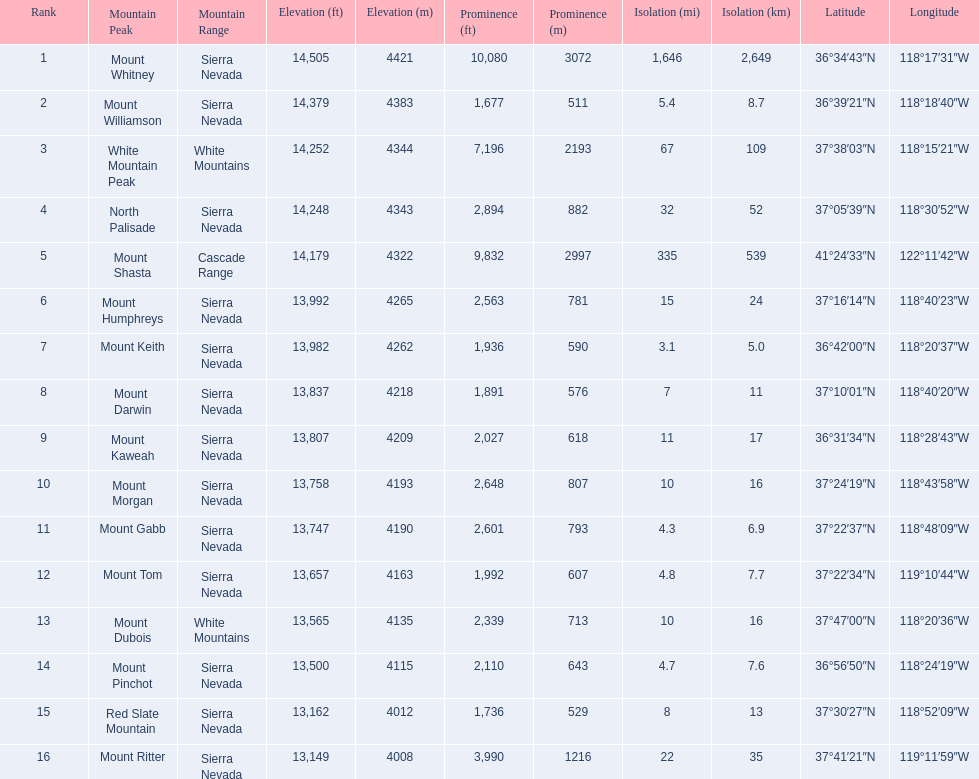What are the listed elevations? 14,505 ft\n4421 m, 14,379 ft\n4383 m, 14,252 ft\n4344 m, 14,248 ft\n4343 m, 14,179 ft\n4322 m, 13,992 ft\n4265 m, 13,982 ft\n4262 m, 13,837 ft\n4218 m, 13,807 ft\n4209 m, 13,758 ft\n4193 m, 13,747 ft\n4190 m, 13,657 ft\n4163 m, 13,565 ft\n4135 m, 13,500 ft\n4115 m, 13,162 ft\n4012 m, 13,149 ft\n4008 m. Which of those is 13,149 ft or below? 13,149 ft\n4008 m. To what mountain peak does that value correspond? Mount Ritter. 